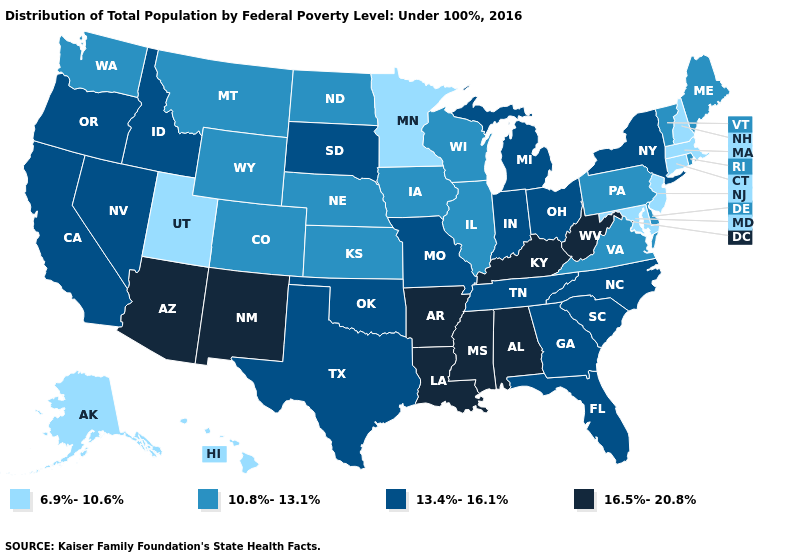Among the states that border Minnesota , which have the lowest value?
Give a very brief answer. Iowa, North Dakota, Wisconsin. What is the value of Louisiana?
Write a very short answer. 16.5%-20.8%. What is the value of North Carolina?
Write a very short answer. 13.4%-16.1%. Name the states that have a value in the range 16.5%-20.8%?
Concise answer only. Alabama, Arizona, Arkansas, Kentucky, Louisiana, Mississippi, New Mexico, West Virginia. Name the states that have a value in the range 10.8%-13.1%?
Be succinct. Colorado, Delaware, Illinois, Iowa, Kansas, Maine, Montana, Nebraska, North Dakota, Pennsylvania, Rhode Island, Vermont, Virginia, Washington, Wisconsin, Wyoming. What is the value of Vermont?
Answer briefly. 10.8%-13.1%. Does South Dakota have the lowest value in the MidWest?
Be succinct. No. What is the value of Delaware?
Write a very short answer. 10.8%-13.1%. Name the states that have a value in the range 16.5%-20.8%?
Write a very short answer. Alabama, Arizona, Arkansas, Kentucky, Louisiana, Mississippi, New Mexico, West Virginia. Name the states that have a value in the range 13.4%-16.1%?
Keep it brief. California, Florida, Georgia, Idaho, Indiana, Michigan, Missouri, Nevada, New York, North Carolina, Ohio, Oklahoma, Oregon, South Carolina, South Dakota, Tennessee, Texas. Name the states that have a value in the range 6.9%-10.6%?
Be succinct. Alaska, Connecticut, Hawaii, Maryland, Massachusetts, Minnesota, New Hampshire, New Jersey, Utah. Does Colorado have the lowest value in the USA?
Be succinct. No. What is the value of Louisiana?
Concise answer only. 16.5%-20.8%. Is the legend a continuous bar?
Keep it brief. No. Does the map have missing data?
Be succinct. No. 